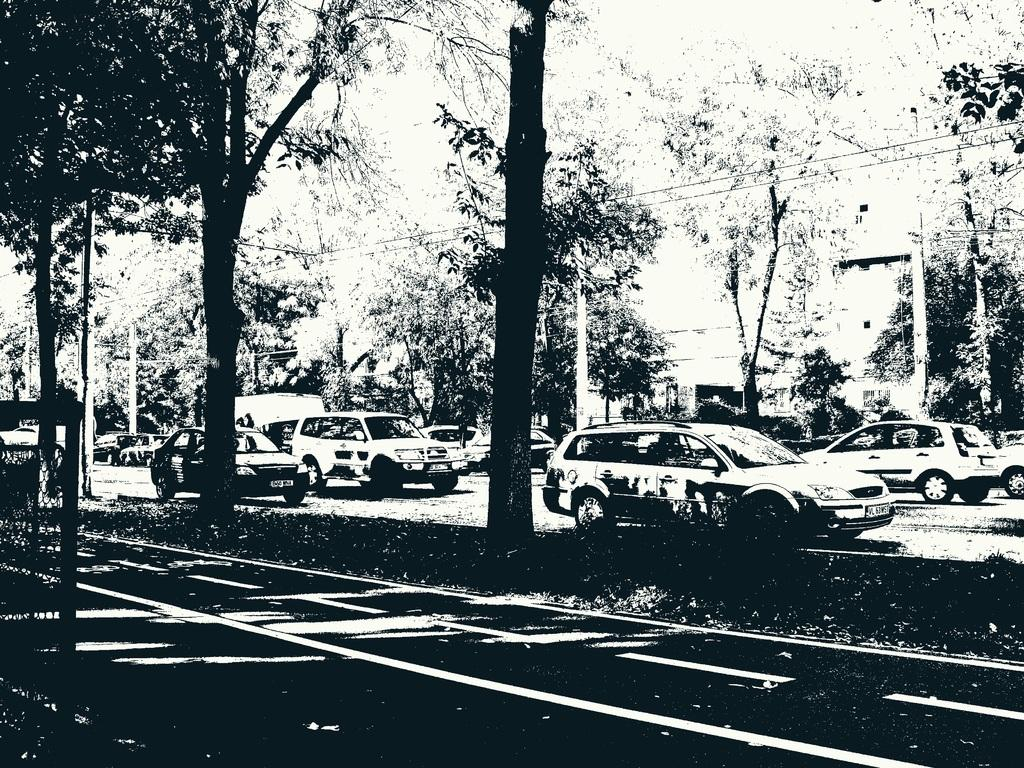What is the color scheme of the image? The image is black and white. What can be seen at the bottom of the image? There is a road at the bottom of the image. What is located in the middle of the image? There are trees in the middle of the image. What is happening on the road in the image? Cars are moving on the road. Can you hear the voice of the father in the image? There is no voice or father present in the image, as it is a black and white image of a road and trees. 